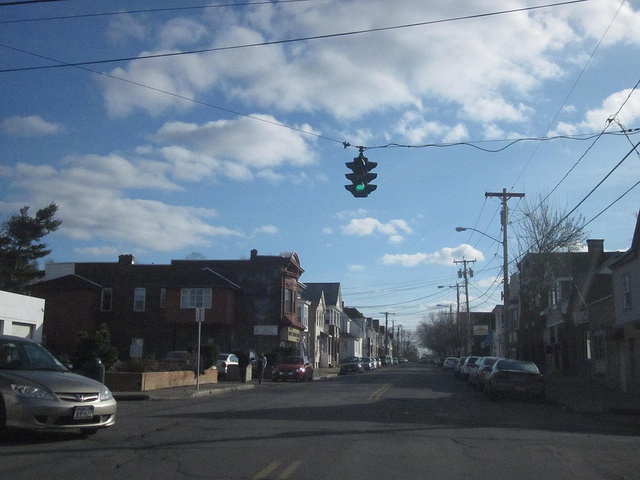Describe the objects in this image and their specific colors. I can see car in blue, black, gray, and darkblue tones, car in blue, black, gray, and darkblue tones, car in blue, black, gray, and purple tones, traffic light in blue, black, teal, and turquoise tones, and car in blue, black, gray, and darkblue tones in this image. 